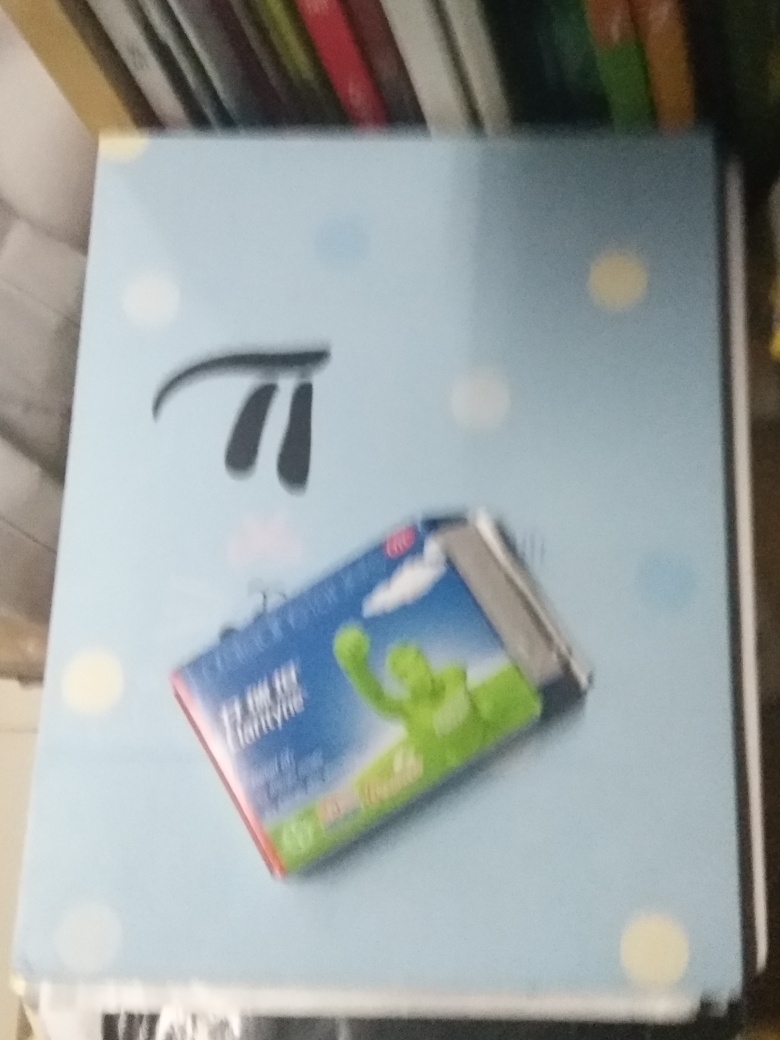Can you speculate why the image is blurry? The blurriness could be the result of a low shutter speed on the camera paired with unsteady hands or motion. It's also possible that the focus was not properly set on the main subject when the photograph was taken. Lastly, the camera may have been too close to the subject for the lens to focus correctly.  Are there any possible artistic reasons for the image's blurriness? While artistic intention is difficult to ascertain without context from the photographer, blurriness can at times be used purposefully to convey movement, dreaminess, or abstraction in a photograph. In this instance, should the blurriness be intentional, it might evoke a sense that the object—the toothpaste—is rapidly moving towards the viewer, suggesting efficiency or ease of use. 